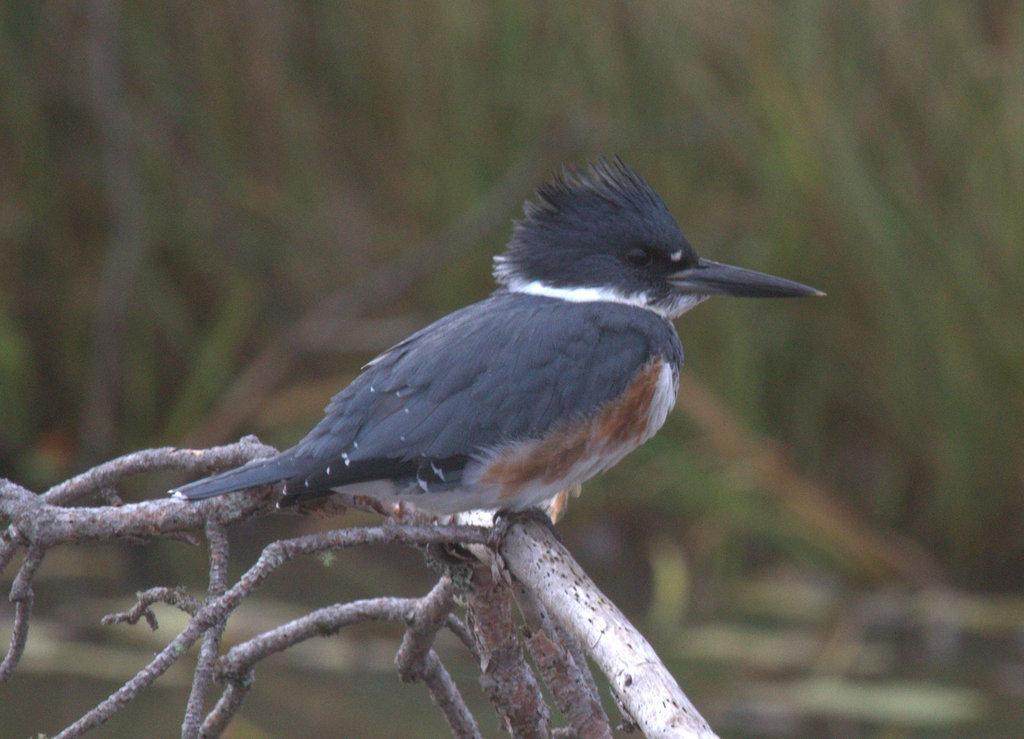Please provide a concise description of this image. In this image I can see a bird which is black, white and brown in color is standing on a tree branch which is cream and ash in color. In the background I can see few trees which are blurry. 